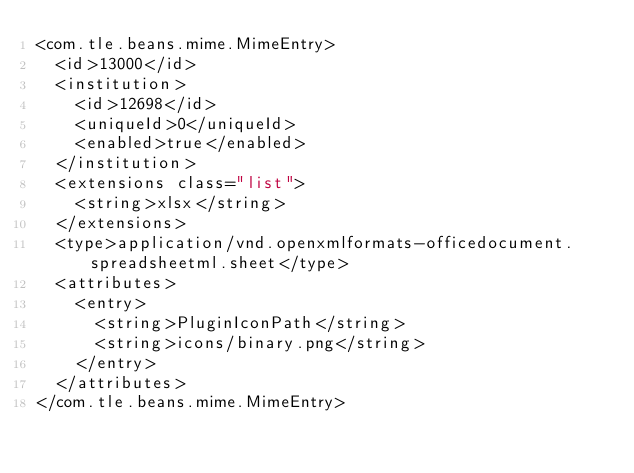<code> <loc_0><loc_0><loc_500><loc_500><_XML_><com.tle.beans.mime.MimeEntry>
  <id>13000</id>
  <institution>
    <id>12698</id>
    <uniqueId>0</uniqueId>
    <enabled>true</enabled>
  </institution>
  <extensions class="list">
    <string>xlsx</string>
  </extensions>
  <type>application/vnd.openxmlformats-officedocument.spreadsheetml.sheet</type>
  <attributes>
    <entry>
      <string>PluginIconPath</string>
      <string>icons/binary.png</string>
    </entry>
  </attributes>
</com.tle.beans.mime.MimeEntry></code> 